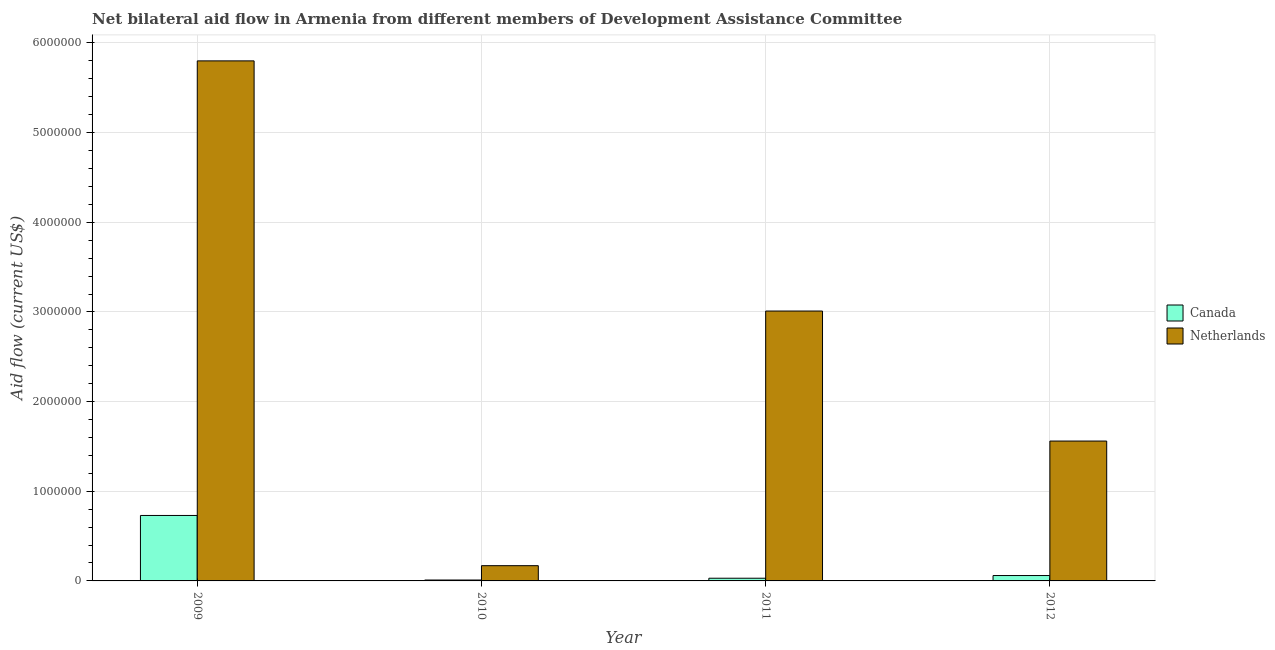How many different coloured bars are there?
Offer a very short reply. 2. How many groups of bars are there?
Offer a terse response. 4. Are the number of bars on each tick of the X-axis equal?
Make the answer very short. Yes. How many bars are there on the 4th tick from the left?
Your answer should be very brief. 2. How many bars are there on the 1st tick from the right?
Offer a terse response. 2. In how many cases, is the number of bars for a given year not equal to the number of legend labels?
Your answer should be very brief. 0. What is the amount of aid given by canada in 2011?
Provide a succinct answer. 3.00e+04. Across all years, what is the maximum amount of aid given by netherlands?
Your response must be concise. 5.80e+06. Across all years, what is the minimum amount of aid given by netherlands?
Ensure brevity in your answer.  1.70e+05. What is the total amount of aid given by netherlands in the graph?
Keep it short and to the point. 1.05e+07. What is the difference between the amount of aid given by netherlands in 2009 and that in 2010?
Ensure brevity in your answer.  5.63e+06. What is the difference between the amount of aid given by canada in 2009 and the amount of aid given by netherlands in 2010?
Your answer should be compact. 7.20e+05. What is the average amount of aid given by canada per year?
Your answer should be compact. 2.08e+05. What is the ratio of the amount of aid given by canada in 2009 to that in 2012?
Your response must be concise. 12.17. Is the difference between the amount of aid given by canada in 2009 and 2012 greater than the difference between the amount of aid given by netherlands in 2009 and 2012?
Your answer should be compact. No. What is the difference between the highest and the second highest amount of aid given by canada?
Offer a very short reply. 6.70e+05. What is the difference between the highest and the lowest amount of aid given by netherlands?
Ensure brevity in your answer.  5.63e+06. What does the 1st bar from the right in 2009 represents?
Keep it short and to the point. Netherlands. What is the difference between two consecutive major ticks on the Y-axis?
Make the answer very short. 1.00e+06. Does the graph contain any zero values?
Give a very brief answer. No. What is the title of the graph?
Give a very brief answer. Net bilateral aid flow in Armenia from different members of Development Assistance Committee. Does "Female labor force" appear as one of the legend labels in the graph?
Offer a terse response. No. What is the Aid flow (current US$) of Canada in 2009?
Your response must be concise. 7.30e+05. What is the Aid flow (current US$) of Netherlands in 2009?
Offer a terse response. 5.80e+06. What is the Aid flow (current US$) of Netherlands in 2011?
Ensure brevity in your answer.  3.01e+06. What is the Aid flow (current US$) of Netherlands in 2012?
Ensure brevity in your answer.  1.56e+06. Across all years, what is the maximum Aid flow (current US$) of Canada?
Provide a short and direct response. 7.30e+05. Across all years, what is the maximum Aid flow (current US$) in Netherlands?
Offer a very short reply. 5.80e+06. Across all years, what is the minimum Aid flow (current US$) in Netherlands?
Make the answer very short. 1.70e+05. What is the total Aid flow (current US$) in Canada in the graph?
Keep it short and to the point. 8.30e+05. What is the total Aid flow (current US$) of Netherlands in the graph?
Keep it short and to the point. 1.05e+07. What is the difference between the Aid flow (current US$) in Canada in 2009 and that in 2010?
Give a very brief answer. 7.20e+05. What is the difference between the Aid flow (current US$) of Netherlands in 2009 and that in 2010?
Ensure brevity in your answer.  5.63e+06. What is the difference between the Aid flow (current US$) of Canada in 2009 and that in 2011?
Your answer should be compact. 7.00e+05. What is the difference between the Aid flow (current US$) in Netherlands in 2009 and that in 2011?
Give a very brief answer. 2.79e+06. What is the difference between the Aid flow (current US$) of Canada in 2009 and that in 2012?
Your response must be concise. 6.70e+05. What is the difference between the Aid flow (current US$) of Netherlands in 2009 and that in 2012?
Make the answer very short. 4.24e+06. What is the difference between the Aid flow (current US$) of Netherlands in 2010 and that in 2011?
Provide a succinct answer. -2.84e+06. What is the difference between the Aid flow (current US$) of Canada in 2010 and that in 2012?
Your answer should be compact. -5.00e+04. What is the difference between the Aid flow (current US$) of Netherlands in 2010 and that in 2012?
Your answer should be compact. -1.39e+06. What is the difference between the Aid flow (current US$) in Netherlands in 2011 and that in 2012?
Your answer should be very brief. 1.45e+06. What is the difference between the Aid flow (current US$) in Canada in 2009 and the Aid flow (current US$) in Netherlands in 2010?
Provide a succinct answer. 5.60e+05. What is the difference between the Aid flow (current US$) of Canada in 2009 and the Aid flow (current US$) of Netherlands in 2011?
Offer a terse response. -2.28e+06. What is the difference between the Aid flow (current US$) of Canada in 2009 and the Aid flow (current US$) of Netherlands in 2012?
Offer a terse response. -8.30e+05. What is the difference between the Aid flow (current US$) of Canada in 2010 and the Aid flow (current US$) of Netherlands in 2011?
Give a very brief answer. -3.00e+06. What is the difference between the Aid flow (current US$) of Canada in 2010 and the Aid flow (current US$) of Netherlands in 2012?
Your answer should be compact. -1.55e+06. What is the difference between the Aid flow (current US$) in Canada in 2011 and the Aid flow (current US$) in Netherlands in 2012?
Make the answer very short. -1.53e+06. What is the average Aid flow (current US$) of Canada per year?
Your answer should be compact. 2.08e+05. What is the average Aid flow (current US$) of Netherlands per year?
Your answer should be compact. 2.64e+06. In the year 2009, what is the difference between the Aid flow (current US$) in Canada and Aid flow (current US$) in Netherlands?
Your answer should be compact. -5.07e+06. In the year 2010, what is the difference between the Aid flow (current US$) of Canada and Aid flow (current US$) of Netherlands?
Your answer should be compact. -1.60e+05. In the year 2011, what is the difference between the Aid flow (current US$) of Canada and Aid flow (current US$) of Netherlands?
Ensure brevity in your answer.  -2.98e+06. In the year 2012, what is the difference between the Aid flow (current US$) in Canada and Aid flow (current US$) in Netherlands?
Offer a very short reply. -1.50e+06. What is the ratio of the Aid flow (current US$) of Netherlands in 2009 to that in 2010?
Your response must be concise. 34.12. What is the ratio of the Aid flow (current US$) of Canada in 2009 to that in 2011?
Give a very brief answer. 24.33. What is the ratio of the Aid flow (current US$) in Netherlands in 2009 to that in 2011?
Provide a short and direct response. 1.93. What is the ratio of the Aid flow (current US$) of Canada in 2009 to that in 2012?
Make the answer very short. 12.17. What is the ratio of the Aid flow (current US$) of Netherlands in 2009 to that in 2012?
Your answer should be compact. 3.72. What is the ratio of the Aid flow (current US$) of Netherlands in 2010 to that in 2011?
Make the answer very short. 0.06. What is the ratio of the Aid flow (current US$) of Canada in 2010 to that in 2012?
Your answer should be very brief. 0.17. What is the ratio of the Aid flow (current US$) in Netherlands in 2010 to that in 2012?
Offer a very short reply. 0.11. What is the ratio of the Aid flow (current US$) in Netherlands in 2011 to that in 2012?
Provide a succinct answer. 1.93. What is the difference between the highest and the second highest Aid flow (current US$) of Canada?
Make the answer very short. 6.70e+05. What is the difference between the highest and the second highest Aid flow (current US$) in Netherlands?
Offer a terse response. 2.79e+06. What is the difference between the highest and the lowest Aid flow (current US$) in Canada?
Your answer should be very brief. 7.20e+05. What is the difference between the highest and the lowest Aid flow (current US$) in Netherlands?
Ensure brevity in your answer.  5.63e+06. 